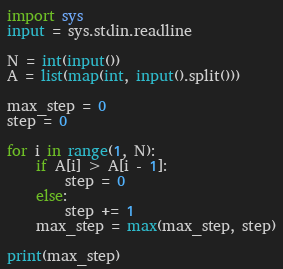<code> <loc_0><loc_0><loc_500><loc_500><_Python_>import sys
input = sys.stdin.readline

N = int(input())
A = list(map(int, input().split()))

max_step = 0
step = 0

for i in range(1, N):
    if A[i] > A[i - 1]:
        step = 0
    else:
        step += 1
    max_step = max(max_step, step)

print(max_step)
</code> 